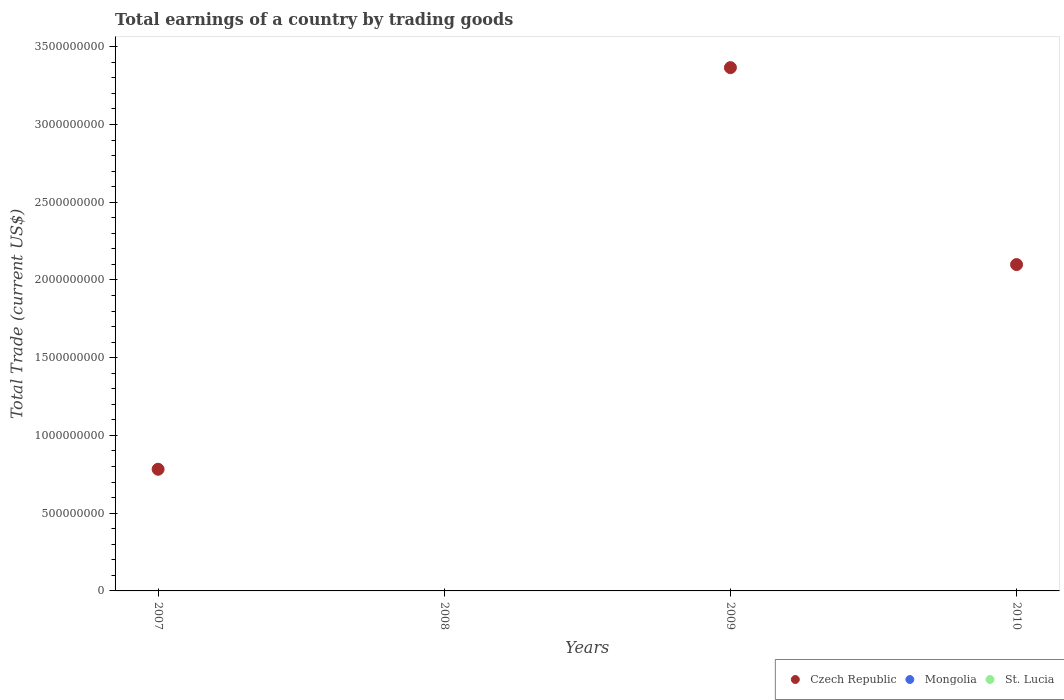Is the number of dotlines equal to the number of legend labels?
Your answer should be compact. No. Across all years, what is the maximum total earnings in Czech Republic?
Give a very brief answer. 3.37e+09. Across all years, what is the minimum total earnings in St. Lucia?
Make the answer very short. 0. What is the total total earnings in Czech Republic in the graph?
Keep it short and to the point. 6.25e+09. What is the difference between the total earnings in Czech Republic in 2007 and that in 2009?
Provide a short and direct response. -2.58e+09. What is the ratio of the total earnings in Czech Republic in 2007 to that in 2010?
Your answer should be compact. 0.37. What is the difference between the highest and the second highest total earnings in Czech Republic?
Your response must be concise. 1.27e+09. What is the difference between the highest and the lowest total earnings in Czech Republic?
Your answer should be compact. 3.37e+09. In how many years, is the total earnings in Czech Republic greater than the average total earnings in Czech Republic taken over all years?
Provide a succinct answer. 2. Is the total earnings in Mongolia strictly greater than the total earnings in St. Lucia over the years?
Your response must be concise. No. Is the total earnings in Czech Republic strictly less than the total earnings in St. Lucia over the years?
Offer a terse response. No. What is the difference between two consecutive major ticks on the Y-axis?
Make the answer very short. 5.00e+08. Where does the legend appear in the graph?
Provide a short and direct response. Bottom right. How are the legend labels stacked?
Your response must be concise. Horizontal. What is the title of the graph?
Offer a very short reply. Total earnings of a country by trading goods. Does "Kenya" appear as one of the legend labels in the graph?
Give a very brief answer. No. What is the label or title of the X-axis?
Your response must be concise. Years. What is the label or title of the Y-axis?
Provide a succinct answer. Total Trade (current US$). What is the Total Trade (current US$) in Czech Republic in 2007?
Your answer should be compact. 7.83e+08. What is the Total Trade (current US$) of Mongolia in 2008?
Give a very brief answer. 0. What is the Total Trade (current US$) in St. Lucia in 2008?
Your answer should be compact. 0. What is the Total Trade (current US$) of Czech Republic in 2009?
Offer a very short reply. 3.37e+09. What is the Total Trade (current US$) in Czech Republic in 2010?
Offer a terse response. 2.10e+09. What is the Total Trade (current US$) in Mongolia in 2010?
Provide a short and direct response. 0. What is the Total Trade (current US$) of St. Lucia in 2010?
Keep it short and to the point. 0. Across all years, what is the maximum Total Trade (current US$) of Czech Republic?
Keep it short and to the point. 3.37e+09. What is the total Total Trade (current US$) of Czech Republic in the graph?
Offer a terse response. 6.25e+09. What is the difference between the Total Trade (current US$) in Czech Republic in 2007 and that in 2009?
Make the answer very short. -2.58e+09. What is the difference between the Total Trade (current US$) of Czech Republic in 2007 and that in 2010?
Give a very brief answer. -1.32e+09. What is the difference between the Total Trade (current US$) in Czech Republic in 2009 and that in 2010?
Give a very brief answer. 1.27e+09. What is the average Total Trade (current US$) of Czech Republic per year?
Make the answer very short. 1.56e+09. What is the average Total Trade (current US$) in Mongolia per year?
Your answer should be very brief. 0. What is the average Total Trade (current US$) of St. Lucia per year?
Your answer should be compact. 0. What is the ratio of the Total Trade (current US$) of Czech Republic in 2007 to that in 2009?
Provide a short and direct response. 0.23. What is the ratio of the Total Trade (current US$) of Czech Republic in 2007 to that in 2010?
Ensure brevity in your answer.  0.37. What is the ratio of the Total Trade (current US$) of Czech Republic in 2009 to that in 2010?
Make the answer very short. 1.6. What is the difference between the highest and the second highest Total Trade (current US$) of Czech Republic?
Your response must be concise. 1.27e+09. What is the difference between the highest and the lowest Total Trade (current US$) in Czech Republic?
Provide a succinct answer. 3.37e+09. 